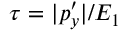Convert formula to latex. <formula><loc_0><loc_0><loc_500><loc_500>\tau = | p _ { y } ^ { \prime } | / E _ { 1 }</formula> 